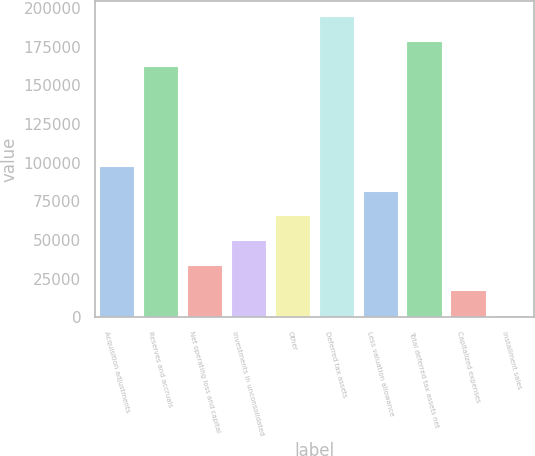Convert chart. <chart><loc_0><loc_0><loc_500><loc_500><bar_chart><fcel>Acquisition adjustments<fcel>Reserves and accruals<fcel>Net operating loss and capital<fcel>Investments in unconsolidated<fcel>Other<fcel>Deferred tax assets<fcel>Less valuation allowance<fcel>Total deferred tax assets net<fcel>Capitalized expenses<fcel>Installment sales<nl><fcel>98039.4<fcel>162395<fcel>33683.8<fcel>49772.7<fcel>65861.6<fcel>194573<fcel>81950.5<fcel>178484<fcel>17594.9<fcel>1506<nl></chart> 